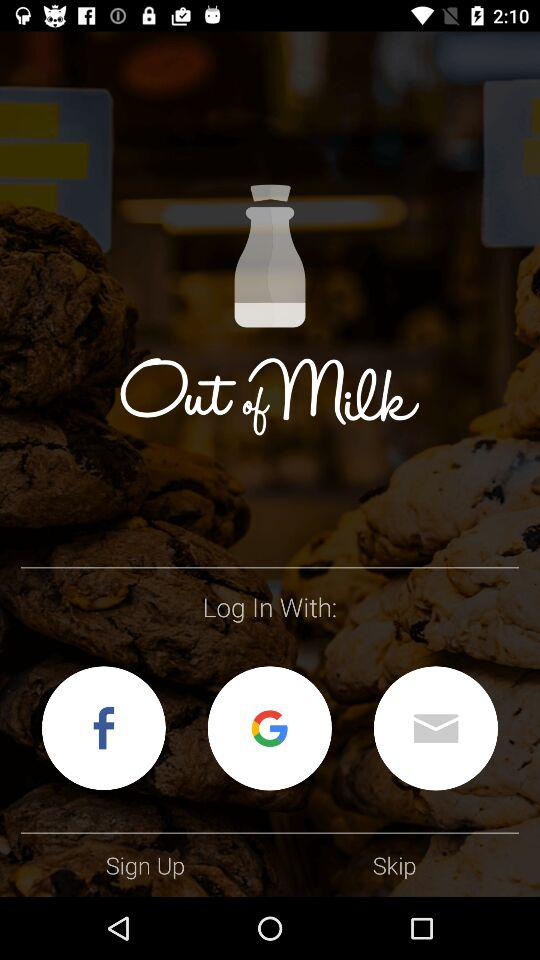What is the app name? The app name is "Out of milk". 